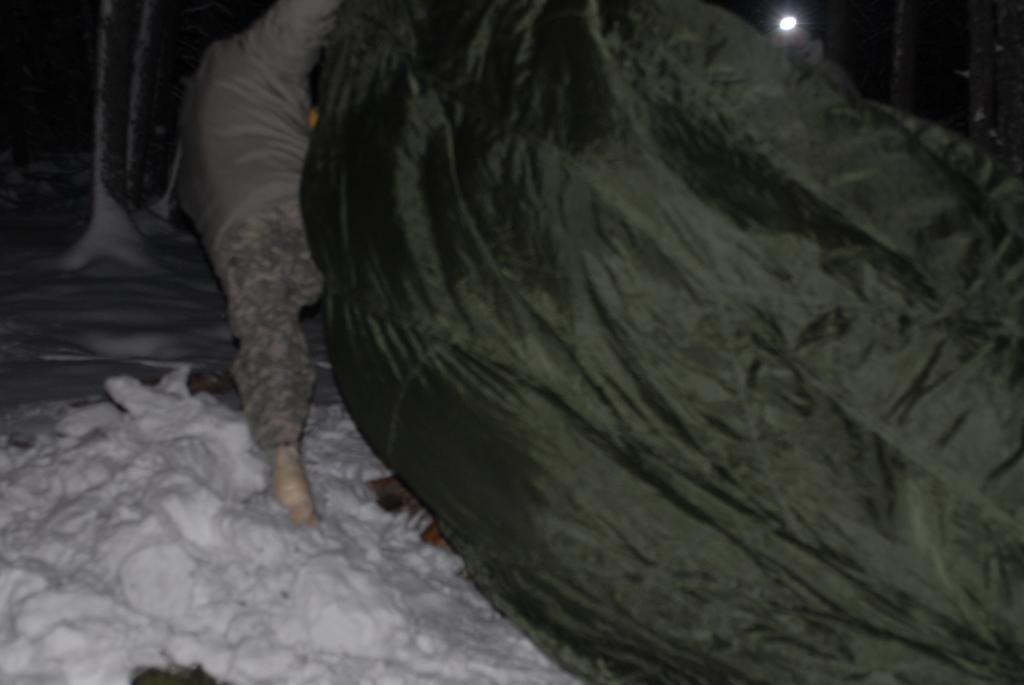What is the person in the image standing on? The person is standing on the snow surface. What color is the cover visible in the image? The cover is black in color. Can you describe the light in the background of the image? There is a light visible in the background of the image. What else can be seen in the background of the image? There are other objects present in the background of the image. What type of meal is the person eating in the image? There is no meal present in the image; the person is standing on the snow surface. What does the person hope to achieve by standing on the snow in the image? The image does not provide any information about the person's hopes or intentions, so we cannot determine what they might be hoping to achieve. 